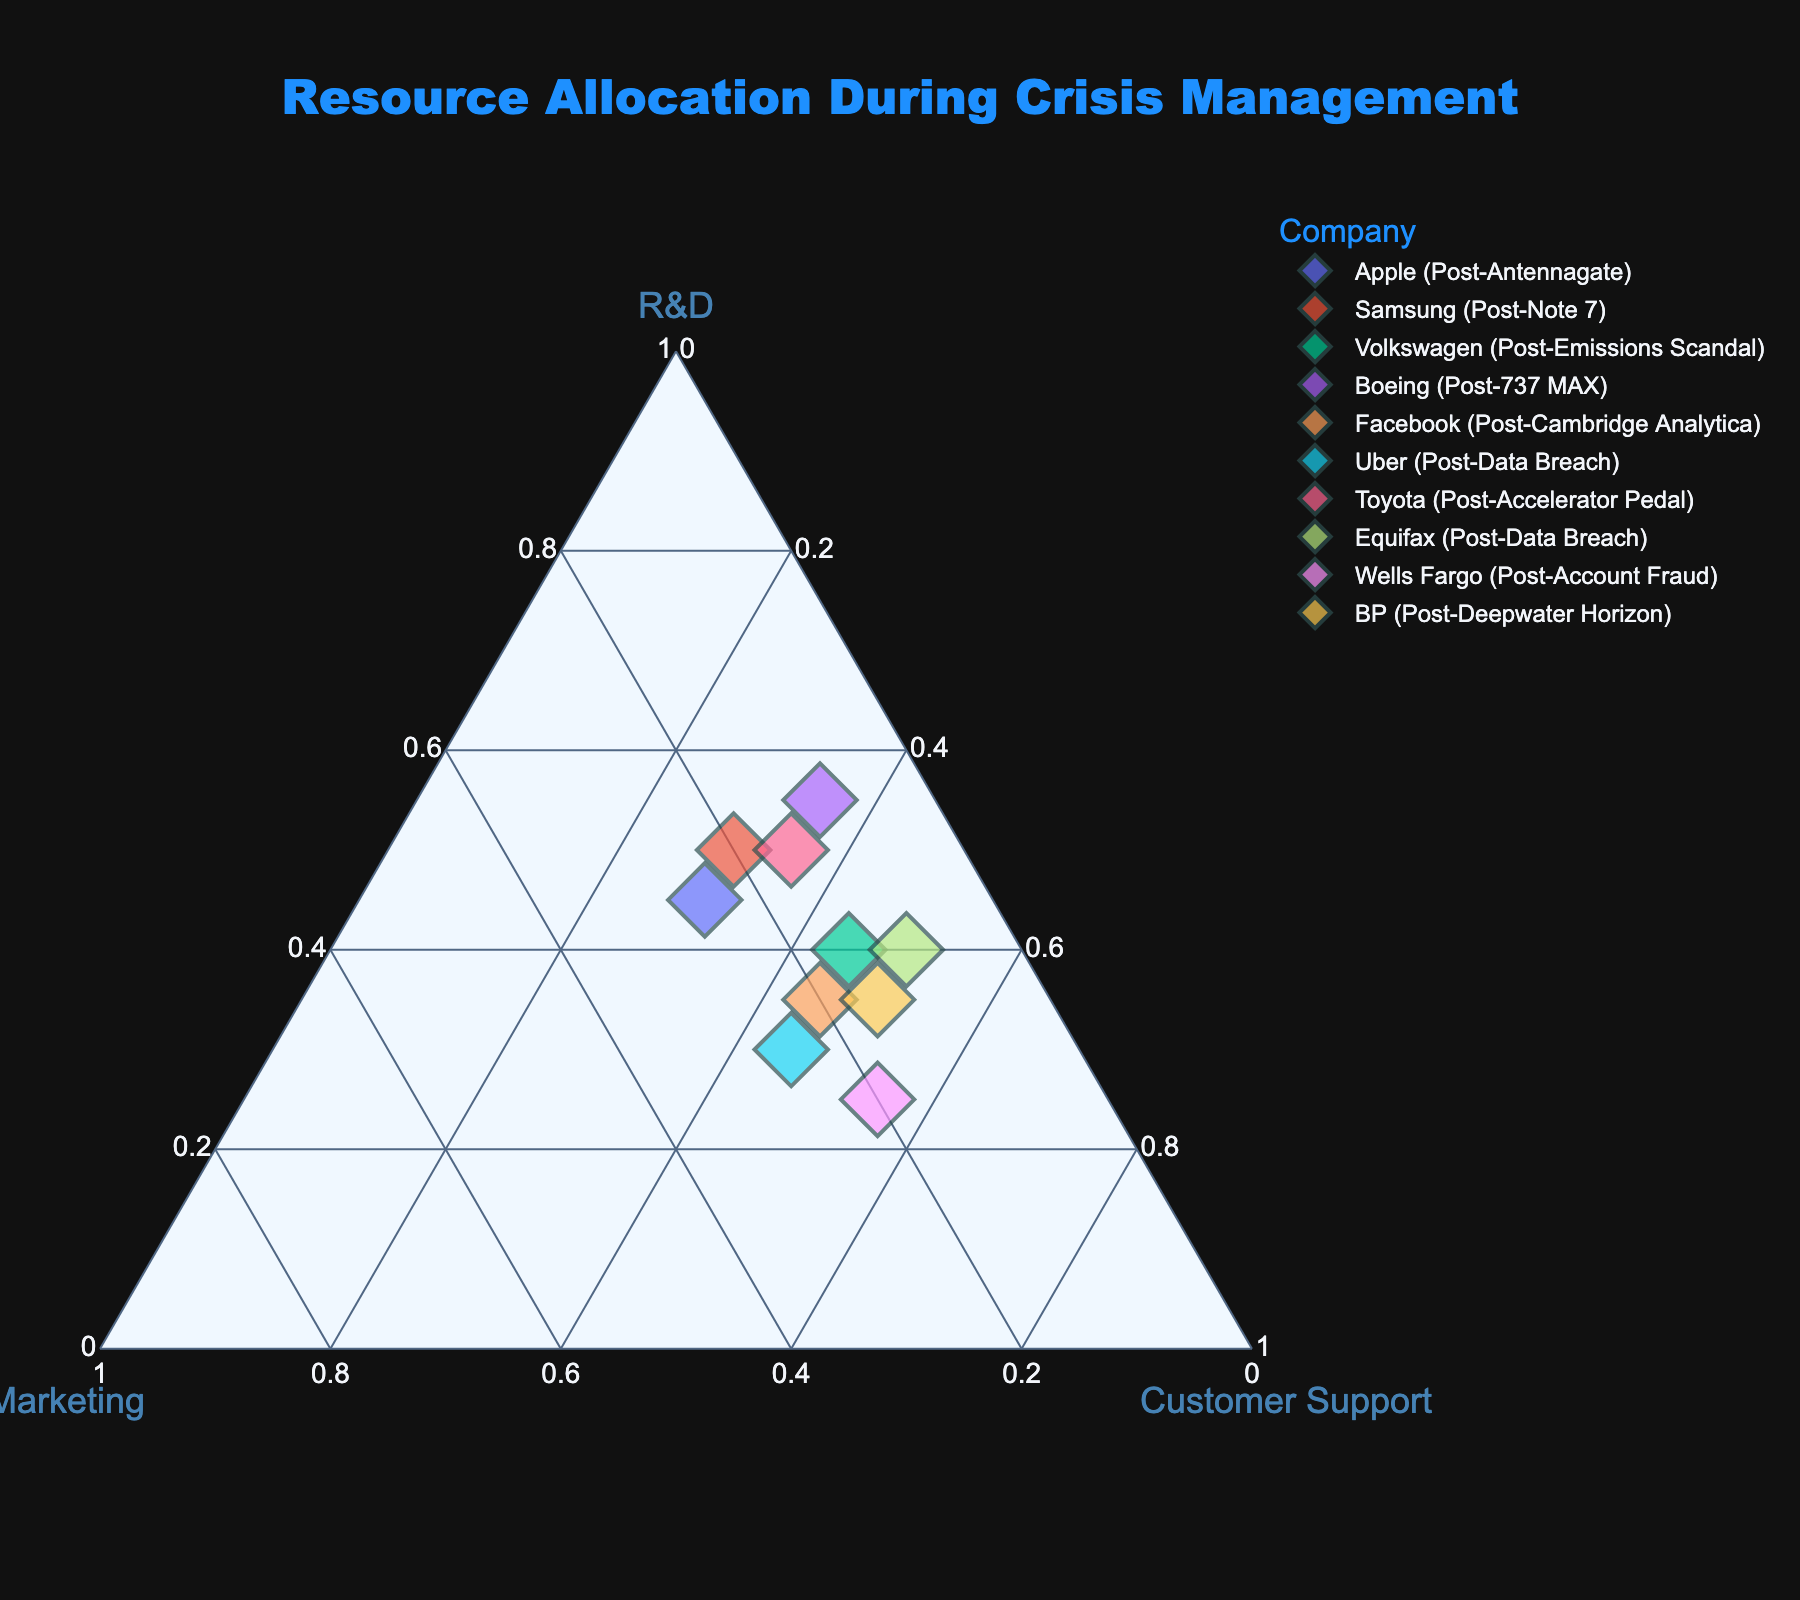What is the title of the plot? The title of a plot is usually located at the top center of the figure. This title gives an overview of what the plot is about. In this case, the title reads "Resource Allocation During Crisis Management".
Answer: Resource Allocation During Crisis Management Which axis represents the allocation to R&D? In a ternary plot, the three corners of the triangle represent different components. Through careful observation, we notice that one of the corners is labeled "R&D". This indicates the axis for Research and Development allocation.
Answer: The axis labeled "R&D" How many companies allocated more than 40% to Customer Support during crisis management? By examining the ternary plot, we focus on the Customer Support axis. The companies that fall closer to this axis’s vertex and beyond the 40% mark are counted. These companies are Facebook, Uber, Equifax, Wells Fargo, and BP.
Answer: 5 companies Comparing Apple and Samsung, which company allocated a higher percentage to Marketing? To make this comparison, we look at the positions of Apple and Samsung on the Marketing axis of the ternary plot. Samsung is closer to the Marketing vertex than Apple.
Answer: Apple allocated more What is the combined allocation percentage for R&D, Marketing, and Customer Support for Volkswagen? Each company’s allocations sum up to 100% in a ternary plot. By examining Volkswagen's position, we observe that it has 40% R&D, 15% Marketing, and 45% Customer Support. Summing these percentages gives us 100%.
Answer: 100% Which company allocated the highest percentage to R&D? We look at each company’s position in relation to the R&D vertex, specifically seeking the company closest to this vertex. Boeing, positioned at 55% R&D, is the highest.
Answer: Boeing What percentage of resources did Wells Fargo allocate to Marketing? Wells Fargo’s position shows that it is significantly far from the Marketing vertex. By examining the plot, we see that it is allocated 20% to Marketing.
Answer: 20% When combining the allocation percentages of Marketing and Customer Support, which company has the smallest value? We need to sum up the Marketing and Customer Support allocations for each company and compare these sums. The smallest comes from Boeing, with 10% Marketing and 35% Customer Support, totaling 45%.
Answer: Boeing Which two companies have equal allocations for Customer Support? By examining the Customer Support percentages from the plot, we notice Apple and Samsung both have 30% allocated to Customer Support.
Answer: Apple and Samsung What is the difference in R&D allocation between Toyota and BP? We find both the values for R&D for Toyota and BP from their positions, and then subtract the smaller value from the larger. Toyota has 50% and BP has 35%, making the difference 15%.
Answer: 15% 